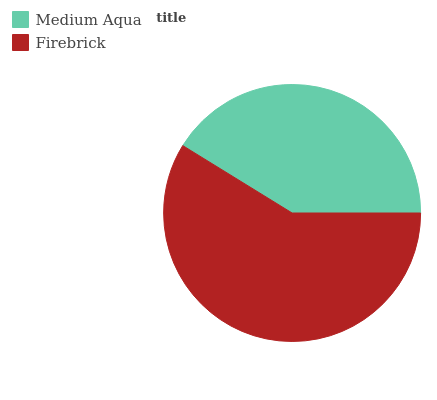Is Medium Aqua the minimum?
Answer yes or no. Yes. Is Firebrick the maximum?
Answer yes or no. Yes. Is Firebrick the minimum?
Answer yes or no. No. Is Firebrick greater than Medium Aqua?
Answer yes or no. Yes. Is Medium Aqua less than Firebrick?
Answer yes or no. Yes. Is Medium Aqua greater than Firebrick?
Answer yes or no. No. Is Firebrick less than Medium Aqua?
Answer yes or no. No. Is Firebrick the high median?
Answer yes or no. Yes. Is Medium Aqua the low median?
Answer yes or no. Yes. Is Medium Aqua the high median?
Answer yes or no. No. Is Firebrick the low median?
Answer yes or no. No. 